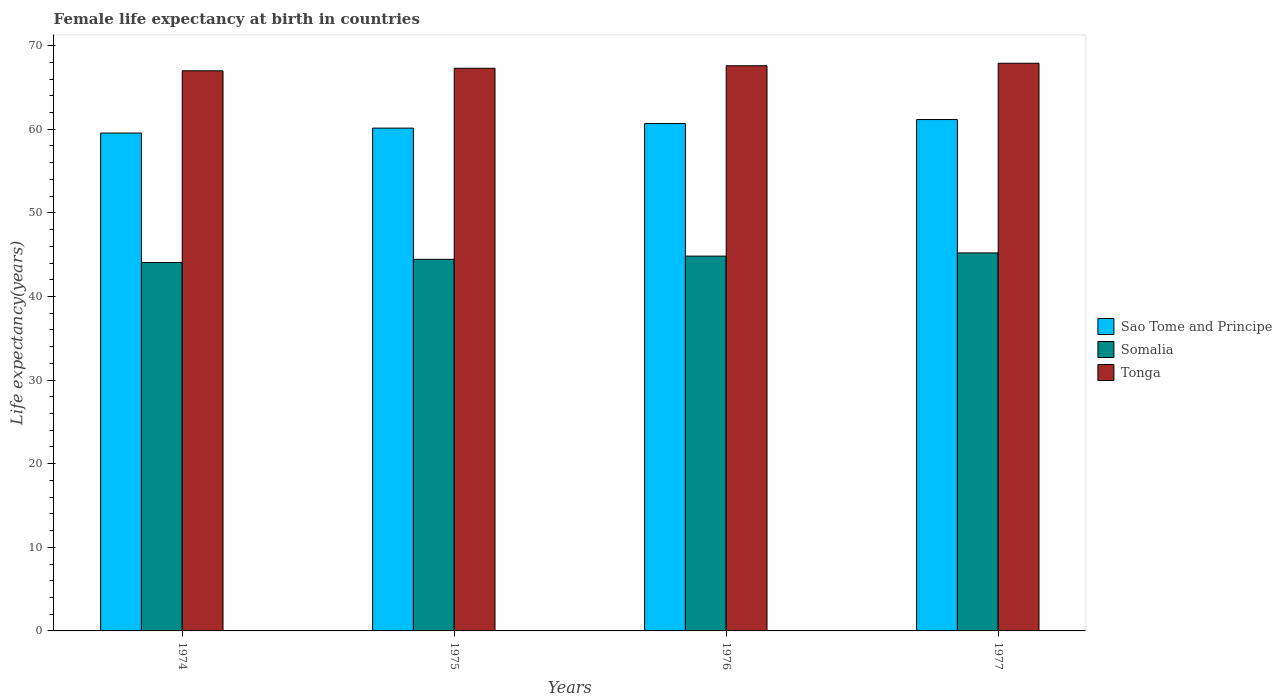How many groups of bars are there?
Your answer should be very brief. 4. How many bars are there on the 4th tick from the right?
Keep it short and to the point. 3. What is the label of the 1st group of bars from the left?
Your response must be concise. 1974. In how many cases, is the number of bars for a given year not equal to the number of legend labels?
Ensure brevity in your answer.  0. What is the female life expectancy at birth in Somalia in 1977?
Provide a short and direct response. 45.21. Across all years, what is the maximum female life expectancy at birth in Sao Tome and Principe?
Keep it short and to the point. 61.16. Across all years, what is the minimum female life expectancy at birth in Sao Tome and Principe?
Your answer should be compact. 59.55. In which year was the female life expectancy at birth in Tonga minimum?
Keep it short and to the point. 1974. What is the total female life expectancy at birth in Tonga in the graph?
Provide a short and direct response. 269.77. What is the difference between the female life expectancy at birth in Somalia in 1974 and that in 1975?
Your response must be concise. -0.38. What is the difference between the female life expectancy at birth in Tonga in 1975 and the female life expectancy at birth in Somalia in 1974?
Give a very brief answer. 23.23. What is the average female life expectancy at birth in Sao Tome and Principe per year?
Provide a short and direct response. 60.38. In the year 1976, what is the difference between the female life expectancy at birth in Somalia and female life expectancy at birth in Sao Tome and Principe?
Provide a succinct answer. -15.85. In how many years, is the female life expectancy at birth in Sao Tome and Principe greater than 2 years?
Keep it short and to the point. 4. What is the ratio of the female life expectancy at birth in Somalia in 1976 to that in 1977?
Ensure brevity in your answer.  0.99. What is the difference between the highest and the second highest female life expectancy at birth in Somalia?
Your answer should be compact. 0.38. What is the difference between the highest and the lowest female life expectancy at birth in Sao Tome and Principe?
Keep it short and to the point. 1.61. In how many years, is the female life expectancy at birth in Tonga greater than the average female life expectancy at birth in Tonga taken over all years?
Make the answer very short. 2. What does the 1st bar from the left in 1974 represents?
Your response must be concise. Sao Tome and Principe. What does the 3rd bar from the right in 1977 represents?
Give a very brief answer. Sao Tome and Principe. Is it the case that in every year, the sum of the female life expectancy at birth in Tonga and female life expectancy at birth in Sao Tome and Principe is greater than the female life expectancy at birth in Somalia?
Provide a succinct answer. Yes. How many bars are there?
Make the answer very short. 12. Are the values on the major ticks of Y-axis written in scientific E-notation?
Offer a terse response. No. How many legend labels are there?
Your response must be concise. 3. What is the title of the graph?
Your response must be concise. Female life expectancy at birth in countries. Does "Tonga" appear as one of the legend labels in the graph?
Make the answer very short. Yes. What is the label or title of the Y-axis?
Ensure brevity in your answer.  Life expectancy(years). What is the Life expectancy(years) in Sao Tome and Principe in 1974?
Give a very brief answer. 59.55. What is the Life expectancy(years) of Somalia in 1974?
Make the answer very short. 44.06. What is the Life expectancy(years) in Tonga in 1974?
Provide a succinct answer. 66.99. What is the Life expectancy(years) in Sao Tome and Principe in 1975?
Your answer should be compact. 60.13. What is the Life expectancy(years) in Somalia in 1975?
Provide a short and direct response. 44.44. What is the Life expectancy(years) in Tonga in 1975?
Your answer should be compact. 67.29. What is the Life expectancy(years) of Sao Tome and Principe in 1976?
Provide a short and direct response. 60.68. What is the Life expectancy(years) in Somalia in 1976?
Provide a succinct answer. 44.83. What is the Life expectancy(years) in Tonga in 1976?
Give a very brief answer. 67.59. What is the Life expectancy(years) in Sao Tome and Principe in 1977?
Provide a succinct answer. 61.16. What is the Life expectancy(years) of Somalia in 1977?
Offer a terse response. 45.21. What is the Life expectancy(years) of Tonga in 1977?
Offer a very short reply. 67.89. Across all years, what is the maximum Life expectancy(years) in Sao Tome and Principe?
Ensure brevity in your answer.  61.16. Across all years, what is the maximum Life expectancy(years) of Somalia?
Offer a terse response. 45.21. Across all years, what is the maximum Life expectancy(years) in Tonga?
Keep it short and to the point. 67.89. Across all years, what is the minimum Life expectancy(years) of Sao Tome and Principe?
Offer a very short reply. 59.55. Across all years, what is the minimum Life expectancy(years) in Somalia?
Make the answer very short. 44.06. Across all years, what is the minimum Life expectancy(years) in Tonga?
Make the answer very short. 66.99. What is the total Life expectancy(years) in Sao Tome and Principe in the graph?
Keep it short and to the point. 241.52. What is the total Life expectancy(years) of Somalia in the graph?
Keep it short and to the point. 178.54. What is the total Life expectancy(years) in Tonga in the graph?
Your response must be concise. 269.77. What is the difference between the Life expectancy(years) in Sao Tome and Principe in 1974 and that in 1975?
Provide a short and direct response. -0.59. What is the difference between the Life expectancy(years) in Somalia in 1974 and that in 1975?
Provide a short and direct response. -0.38. What is the difference between the Life expectancy(years) of Tonga in 1974 and that in 1975?
Offer a very short reply. -0.3. What is the difference between the Life expectancy(years) in Sao Tome and Principe in 1974 and that in 1976?
Your response must be concise. -1.13. What is the difference between the Life expectancy(years) of Somalia in 1974 and that in 1976?
Make the answer very short. -0.76. What is the difference between the Life expectancy(years) in Tonga in 1974 and that in 1976?
Provide a short and direct response. -0.6. What is the difference between the Life expectancy(years) in Sao Tome and Principe in 1974 and that in 1977?
Give a very brief answer. -1.61. What is the difference between the Life expectancy(years) in Somalia in 1974 and that in 1977?
Your response must be concise. -1.15. What is the difference between the Life expectancy(years) of Tonga in 1974 and that in 1977?
Give a very brief answer. -0.9. What is the difference between the Life expectancy(years) in Sao Tome and Principe in 1975 and that in 1976?
Make the answer very short. -0.55. What is the difference between the Life expectancy(years) in Somalia in 1975 and that in 1976?
Give a very brief answer. -0.38. What is the difference between the Life expectancy(years) in Tonga in 1975 and that in 1976?
Give a very brief answer. -0.3. What is the difference between the Life expectancy(years) of Sao Tome and Principe in 1975 and that in 1977?
Your response must be concise. -1.02. What is the difference between the Life expectancy(years) in Somalia in 1975 and that in 1977?
Offer a terse response. -0.77. What is the difference between the Life expectancy(years) of Tonga in 1975 and that in 1977?
Offer a terse response. -0.6. What is the difference between the Life expectancy(years) of Sao Tome and Principe in 1976 and that in 1977?
Offer a very short reply. -0.48. What is the difference between the Life expectancy(years) of Somalia in 1976 and that in 1977?
Ensure brevity in your answer.  -0.38. What is the difference between the Life expectancy(years) in Tonga in 1976 and that in 1977?
Provide a succinct answer. -0.3. What is the difference between the Life expectancy(years) of Sao Tome and Principe in 1974 and the Life expectancy(years) of Somalia in 1975?
Keep it short and to the point. 15.1. What is the difference between the Life expectancy(years) in Sao Tome and Principe in 1974 and the Life expectancy(years) in Tonga in 1975?
Ensure brevity in your answer.  -7.75. What is the difference between the Life expectancy(years) in Somalia in 1974 and the Life expectancy(years) in Tonga in 1975?
Your answer should be very brief. -23.23. What is the difference between the Life expectancy(years) in Sao Tome and Principe in 1974 and the Life expectancy(years) in Somalia in 1976?
Keep it short and to the point. 14.72. What is the difference between the Life expectancy(years) of Sao Tome and Principe in 1974 and the Life expectancy(years) of Tonga in 1976?
Offer a very short reply. -8.05. What is the difference between the Life expectancy(years) of Somalia in 1974 and the Life expectancy(years) of Tonga in 1976?
Make the answer very short. -23.53. What is the difference between the Life expectancy(years) of Sao Tome and Principe in 1974 and the Life expectancy(years) of Somalia in 1977?
Provide a short and direct response. 14.34. What is the difference between the Life expectancy(years) in Sao Tome and Principe in 1974 and the Life expectancy(years) in Tonga in 1977?
Make the answer very short. -8.35. What is the difference between the Life expectancy(years) of Somalia in 1974 and the Life expectancy(years) of Tonga in 1977?
Keep it short and to the point. -23.83. What is the difference between the Life expectancy(years) in Sao Tome and Principe in 1975 and the Life expectancy(years) in Somalia in 1976?
Your answer should be very brief. 15.31. What is the difference between the Life expectancy(years) of Sao Tome and Principe in 1975 and the Life expectancy(years) of Tonga in 1976?
Provide a succinct answer. -7.46. What is the difference between the Life expectancy(years) in Somalia in 1975 and the Life expectancy(years) in Tonga in 1976?
Your response must be concise. -23.15. What is the difference between the Life expectancy(years) in Sao Tome and Principe in 1975 and the Life expectancy(years) in Somalia in 1977?
Offer a very short reply. 14.93. What is the difference between the Life expectancy(years) of Sao Tome and Principe in 1975 and the Life expectancy(years) of Tonga in 1977?
Your answer should be very brief. -7.76. What is the difference between the Life expectancy(years) of Somalia in 1975 and the Life expectancy(years) of Tonga in 1977?
Keep it short and to the point. -23.45. What is the difference between the Life expectancy(years) in Sao Tome and Principe in 1976 and the Life expectancy(years) in Somalia in 1977?
Keep it short and to the point. 15.47. What is the difference between the Life expectancy(years) of Sao Tome and Principe in 1976 and the Life expectancy(years) of Tonga in 1977?
Keep it short and to the point. -7.21. What is the difference between the Life expectancy(years) in Somalia in 1976 and the Life expectancy(years) in Tonga in 1977?
Your response must be concise. -23.07. What is the average Life expectancy(years) of Sao Tome and Principe per year?
Keep it short and to the point. 60.38. What is the average Life expectancy(years) in Somalia per year?
Your answer should be very brief. 44.64. What is the average Life expectancy(years) of Tonga per year?
Provide a short and direct response. 67.44. In the year 1974, what is the difference between the Life expectancy(years) in Sao Tome and Principe and Life expectancy(years) in Somalia?
Your response must be concise. 15.48. In the year 1974, what is the difference between the Life expectancy(years) in Sao Tome and Principe and Life expectancy(years) in Tonga?
Offer a very short reply. -7.44. In the year 1974, what is the difference between the Life expectancy(years) of Somalia and Life expectancy(years) of Tonga?
Give a very brief answer. -22.93. In the year 1975, what is the difference between the Life expectancy(years) of Sao Tome and Principe and Life expectancy(years) of Somalia?
Offer a terse response. 15.69. In the year 1975, what is the difference between the Life expectancy(years) in Sao Tome and Principe and Life expectancy(years) in Tonga?
Offer a terse response. -7.16. In the year 1975, what is the difference between the Life expectancy(years) of Somalia and Life expectancy(years) of Tonga?
Provide a succinct answer. -22.85. In the year 1976, what is the difference between the Life expectancy(years) of Sao Tome and Principe and Life expectancy(years) of Somalia?
Ensure brevity in your answer.  15.85. In the year 1976, what is the difference between the Life expectancy(years) of Sao Tome and Principe and Life expectancy(years) of Tonga?
Your response must be concise. -6.92. In the year 1976, what is the difference between the Life expectancy(years) of Somalia and Life expectancy(years) of Tonga?
Your answer should be compact. -22.77. In the year 1977, what is the difference between the Life expectancy(years) of Sao Tome and Principe and Life expectancy(years) of Somalia?
Your answer should be very brief. 15.95. In the year 1977, what is the difference between the Life expectancy(years) of Sao Tome and Principe and Life expectancy(years) of Tonga?
Your answer should be very brief. -6.73. In the year 1977, what is the difference between the Life expectancy(years) of Somalia and Life expectancy(years) of Tonga?
Your answer should be compact. -22.68. What is the ratio of the Life expectancy(years) of Sao Tome and Principe in 1974 to that in 1975?
Give a very brief answer. 0.99. What is the ratio of the Life expectancy(years) in Tonga in 1974 to that in 1975?
Provide a succinct answer. 1. What is the ratio of the Life expectancy(years) in Sao Tome and Principe in 1974 to that in 1976?
Ensure brevity in your answer.  0.98. What is the ratio of the Life expectancy(years) of Somalia in 1974 to that in 1976?
Provide a short and direct response. 0.98. What is the ratio of the Life expectancy(years) of Sao Tome and Principe in 1974 to that in 1977?
Ensure brevity in your answer.  0.97. What is the ratio of the Life expectancy(years) in Somalia in 1974 to that in 1977?
Provide a short and direct response. 0.97. What is the ratio of the Life expectancy(years) in Tonga in 1974 to that in 1977?
Provide a short and direct response. 0.99. What is the ratio of the Life expectancy(years) of Sao Tome and Principe in 1975 to that in 1976?
Give a very brief answer. 0.99. What is the ratio of the Life expectancy(years) of Somalia in 1975 to that in 1976?
Provide a succinct answer. 0.99. What is the ratio of the Life expectancy(years) in Tonga in 1975 to that in 1976?
Give a very brief answer. 1. What is the ratio of the Life expectancy(years) of Sao Tome and Principe in 1975 to that in 1977?
Ensure brevity in your answer.  0.98. What is the ratio of the Life expectancy(years) in Somalia in 1975 to that in 1977?
Provide a succinct answer. 0.98. What is the ratio of the Life expectancy(years) in Tonga in 1975 to that in 1977?
Your answer should be compact. 0.99. What is the ratio of the Life expectancy(years) of Sao Tome and Principe in 1976 to that in 1977?
Make the answer very short. 0.99. What is the ratio of the Life expectancy(years) in Somalia in 1976 to that in 1977?
Your response must be concise. 0.99. What is the difference between the highest and the second highest Life expectancy(years) in Sao Tome and Principe?
Keep it short and to the point. 0.48. What is the difference between the highest and the second highest Life expectancy(years) in Somalia?
Keep it short and to the point. 0.38. What is the difference between the highest and the second highest Life expectancy(years) of Tonga?
Offer a terse response. 0.3. What is the difference between the highest and the lowest Life expectancy(years) in Sao Tome and Principe?
Keep it short and to the point. 1.61. What is the difference between the highest and the lowest Life expectancy(years) in Somalia?
Your response must be concise. 1.15. What is the difference between the highest and the lowest Life expectancy(years) in Tonga?
Provide a succinct answer. 0.9. 